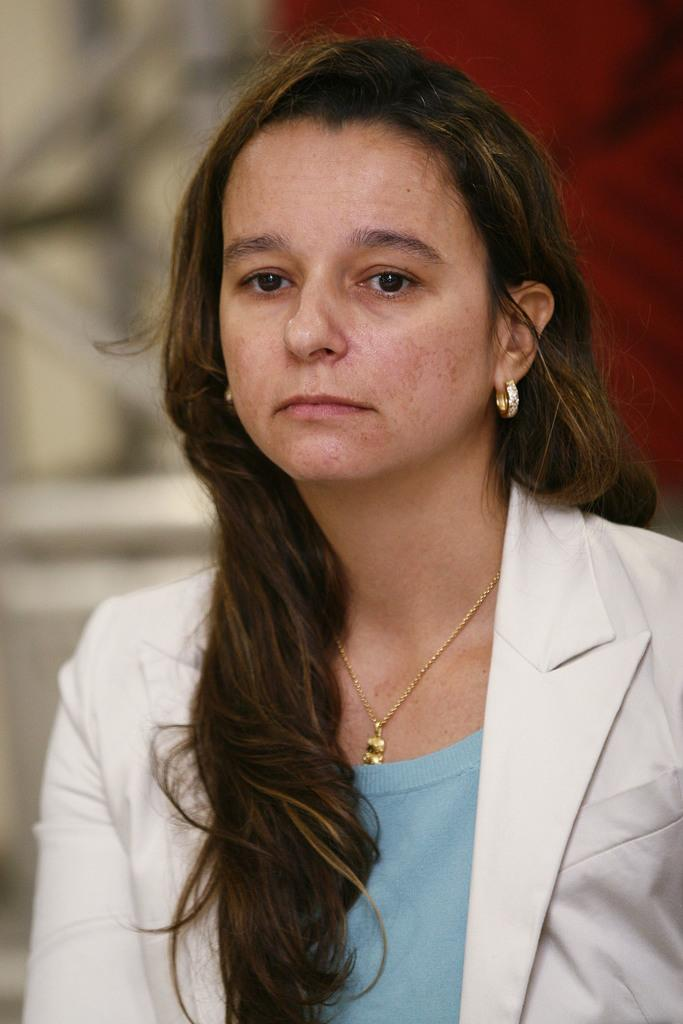Who is present in the image? There is a woman in the image. What accessories is the woman wearing? The woman is wearing earrings and a chain. What type of clothing is the woman wearing? The woman is wearing a suit. Can you describe the background of the image? The background of the image is blurred. What type of fan is visible in the image? There is no fan present in the image. What disease is the woman suffering from in the image? There is no indication of any disease in the image. 